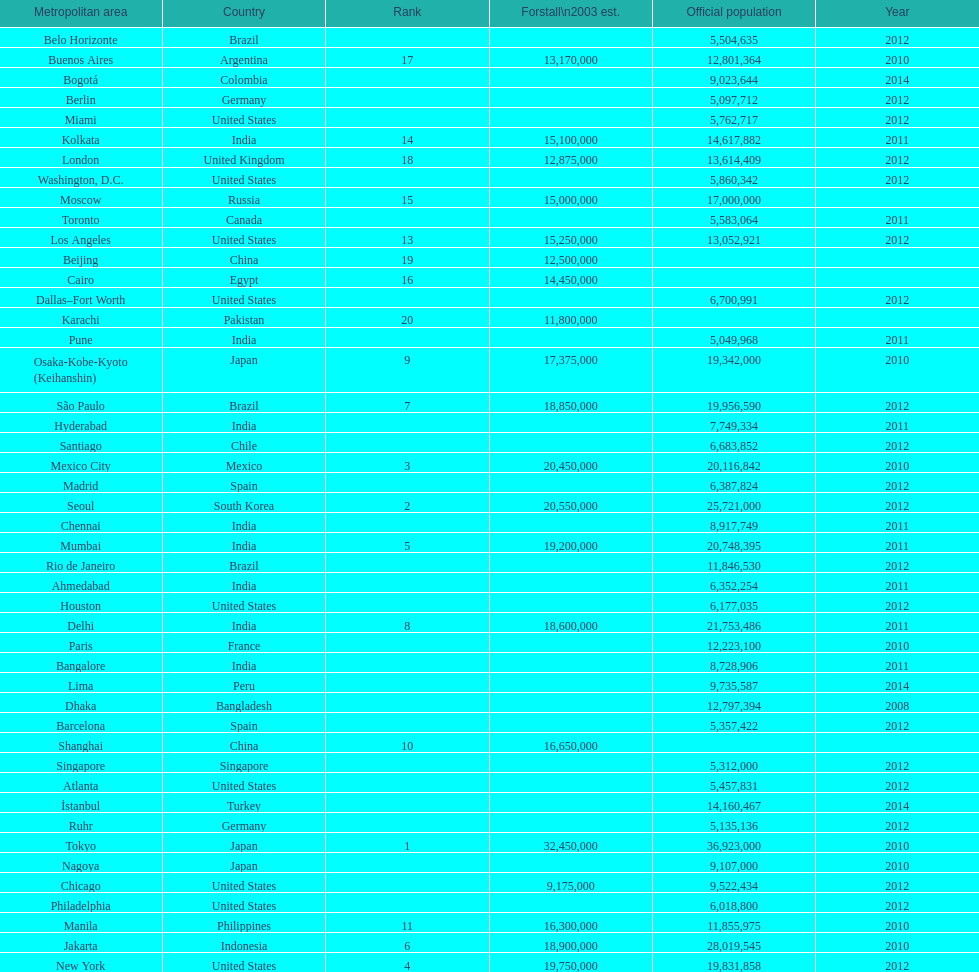What city was ranked first in 2003? Tokyo. I'm looking to parse the entire table for insights. Could you assist me with that? {'header': ['Metropolitan area', 'Country', 'Rank', 'Forstall\\n2003 est.', 'Official population', 'Year'], 'rows': [['Belo Horizonte', 'Brazil', '', '', '5,504,635', '2012'], ['Buenos Aires', 'Argentina', '17', '13,170,000', '12,801,364', '2010'], ['Bogotá', 'Colombia', '', '', '9,023,644', '2014'], ['Berlin', 'Germany', '', '', '5,097,712', '2012'], ['Miami', 'United States', '', '', '5,762,717', '2012'], ['Kolkata', 'India', '14', '15,100,000', '14,617,882', '2011'], ['London', 'United Kingdom', '18', '12,875,000', '13,614,409', '2012'], ['Washington, D.C.', 'United States', '', '', '5,860,342', '2012'], ['Moscow', 'Russia', '15', '15,000,000', '17,000,000', ''], ['Toronto', 'Canada', '', '', '5,583,064', '2011'], ['Los Angeles', 'United States', '13', '15,250,000', '13,052,921', '2012'], ['Beijing', 'China', '19', '12,500,000', '', ''], ['Cairo', 'Egypt', '16', '14,450,000', '', ''], ['Dallas–Fort Worth', 'United States', '', '', '6,700,991', '2012'], ['Karachi', 'Pakistan', '20', '11,800,000', '', ''], ['Pune', 'India', '', '', '5,049,968', '2011'], ['Osaka-Kobe-Kyoto (Keihanshin)', 'Japan', '9', '17,375,000', '19,342,000', '2010'], ['São Paulo', 'Brazil', '7', '18,850,000', '19,956,590', '2012'], ['Hyderabad', 'India', '', '', '7,749,334', '2011'], ['Santiago', 'Chile', '', '', '6,683,852', '2012'], ['Mexico City', 'Mexico', '3', '20,450,000', '20,116,842', '2010'], ['Madrid', 'Spain', '', '', '6,387,824', '2012'], ['Seoul', 'South Korea', '2', '20,550,000', '25,721,000', '2012'], ['Chennai', 'India', '', '', '8,917,749', '2011'], ['Mumbai', 'India', '5', '19,200,000', '20,748,395', '2011'], ['Rio de Janeiro', 'Brazil', '', '', '11,846,530', '2012'], ['Ahmedabad', 'India', '', '', '6,352,254', '2011'], ['Houston', 'United States', '', '', '6,177,035', '2012'], ['Delhi', 'India', '8', '18,600,000', '21,753,486', '2011'], ['Paris', 'France', '', '', '12,223,100', '2010'], ['Bangalore', 'India', '', '', '8,728,906', '2011'], ['Lima', 'Peru', '', '', '9,735,587', '2014'], ['Dhaka', 'Bangladesh', '', '', '12,797,394', '2008'], ['Barcelona', 'Spain', '', '', '5,357,422', '2012'], ['Shanghai', 'China', '10', '16,650,000', '', ''], ['Singapore', 'Singapore', '', '', '5,312,000', '2012'], ['Atlanta', 'United States', '', '', '5,457,831', '2012'], ['İstanbul', 'Turkey', '', '', '14,160,467', '2014'], ['Ruhr', 'Germany', '', '', '5,135,136', '2012'], ['Tokyo', 'Japan', '1', '32,450,000', '36,923,000', '2010'], ['Nagoya', 'Japan', '', '', '9,107,000', '2010'], ['Chicago', 'United States', '', '9,175,000', '9,522,434', '2012'], ['Philadelphia', 'United States', '', '', '6,018,800', '2012'], ['Manila', 'Philippines', '11', '16,300,000', '11,855,975', '2010'], ['Jakarta', 'Indonesia', '6', '18,900,000', '28,019,545', '2010'], ['New York', 'United States', '4', '19,750,000', '19,831,858', '2012']]} 